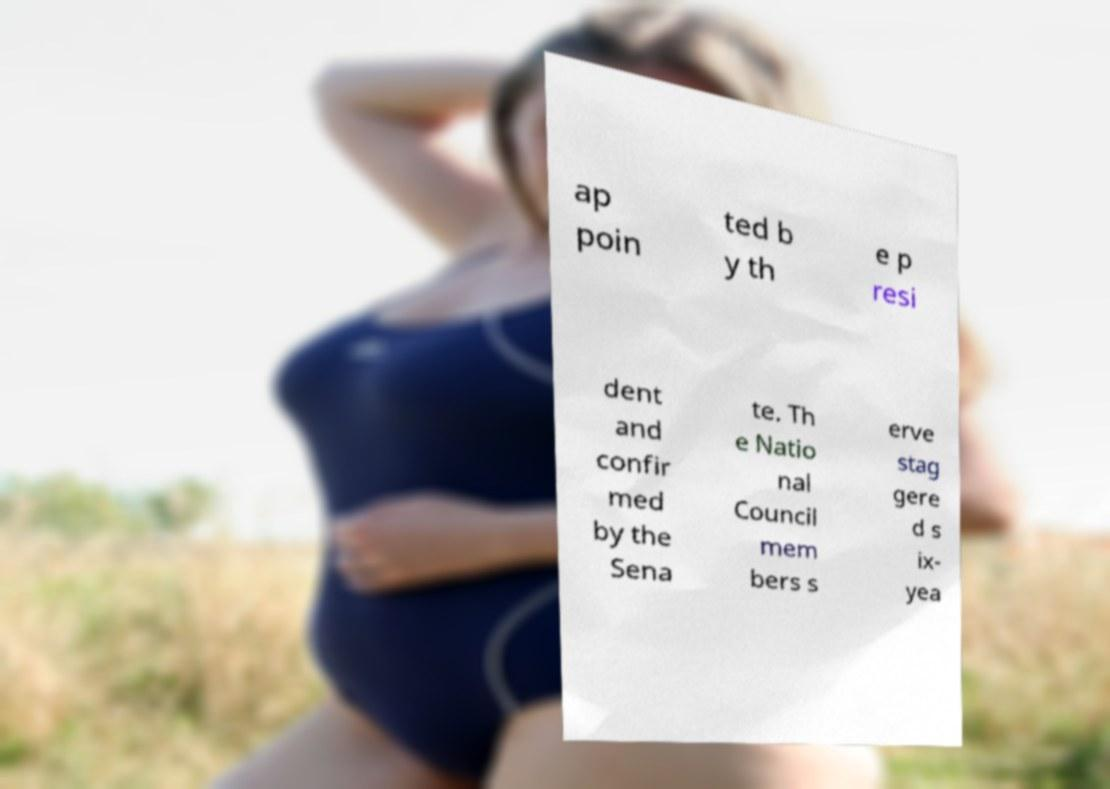There's text embedded in this image that I need extracted. Can you transcribe it verbatim? ap poin ted b y th e p resi dent and confir med by the Sena te. Th e Natio nal Council mem bers s erve stag gere d s ix- yea 